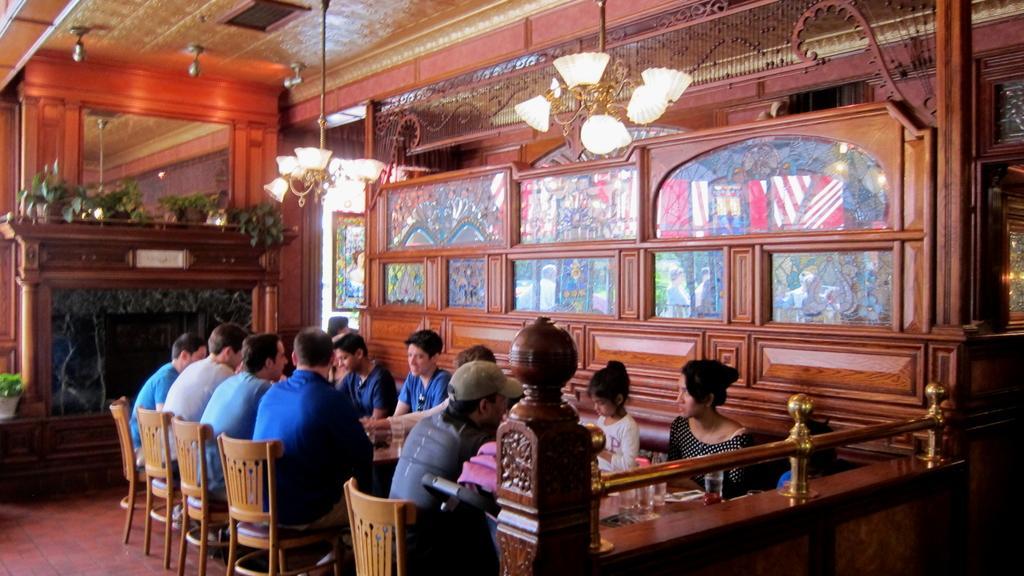In one or two sentences, can you explain what this image depicts? Here we can see a group of people are sitting on the chair, and in front here is the table and glasses and some objects on it, and here is the light, and here is the roof. 